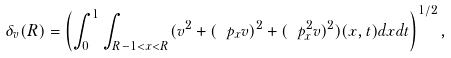<formula> <loc_0><loc_0><loc_500><loc_500>\delta _ { v } ( R ) = \left ( \int _ { 0 } ^ { 1 } \int _ { R - 1 < x < R } ( v ^ { 2 } + ( \ p _ { x } v ) ^ { 2 } + ( \ p _ { x } ^ { 2 } v ) ^ { 2 } ) ( x , t ) d x d t \right ) ^ { 1 / 2 } ,</formula> 